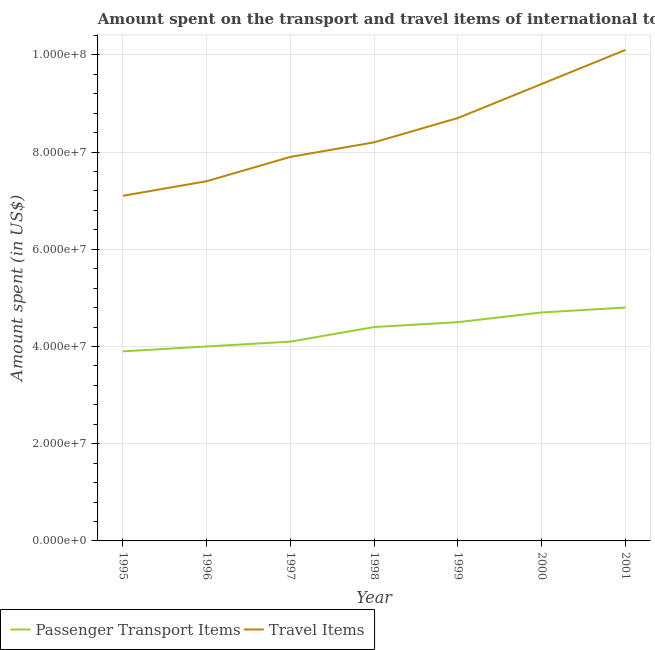How many different coloured lines are there?
Your answer should be very brief. 2. Does the line corresponding to amount spent in travel items intersect with the line corresponding to amount spent on passenger transport items?
Provide a succinct answer. No. Is the number of lines equal to the number of legend labels?
Ensure brevity in your answer.  Yes. What is the amount spent in travel items in 1997?
Make the answer very short. 7.90e+07. Across all years, what is the maximum amount spent on passenger transport items?
Give a very brief answer. 4.80e+07. Across all years, what is the minimum amount spent on passenger transport items?
Your answer should be compact. 3.90e+07. In which year was the amount spent on passenger transport items maximum?
Your answer should be very brief. 2001. What is the total amount spent in travel items in the graph?
Give a very brief answer. 5.88e+08. What is the difference between the amount spent on passenger transport items in 1996 and that in 1997?
Ensure brevity in your answer.  -1.00e+06. What is the difference between the amount spent on passenger transport items in 1998 and the amount spent in travel items in 1996?
Provide a short and direct response. -3.00e+07. What is the average amount spent in travel items per year?
Your answer should be compact. 8.40e+07. In the year 2000, what is the difference between the amount spent on passenger transport items and amount spent in travel items?
Make the answer very short. -4.70e+07. What is the ratio of the amount spent on passenger transport items in 1996 to that in 1997?
Offer a terse response. 0.98. Is the amount spent on passenger transport items in 1999 less than that in 2001?
Keep it short and to the point. Yes. Is the difference between the amount spent in travel items in 1995 and 1997 greater than the difference between the amount spent on passenger transport items in 1995 and 1997?
Your answer should be very brief. No. What is the difference between the highest and the lowest amount spent on passenger transport items?
Make the answer very short. 9.00e+06. In how many years, is the amount spent on passenger transport items greater than the average amount spent on passenger transport items taken over all years?
Provide a succinct answer. 4. Is the amount spent in travel items strictly less than the amount spent on passenger transport items over the years?
Offer a very short reply. No. How many years are there in the graph?
Provide a short and direct response. 7. What is the difference between two consecutive major ticks on the Y-axis?
Make the answer very short. 2.00e+07. Are the values on the major ticks of Y-axis written in scientific E-notation?
Give a very brief answer. Yes. Does the graph contain any zero values?
Provide a short and direct response. No. Does the graph contain grids?
Provide a short and direct response. Yes. How many legend labels are there?
Make the answer very short. 2. What is the title of the graph?
Offer a very short reply. Amount spent on the transport and travel items of international tourists visited in Barbados. Does "Drinking water services" appear as one of the legend labels in the graph?
Give a very brief answer. No. What is the label or title of the X-axis?
Make the answer very short. Year. What is the label or title of the Y-axis?
Make the answer very short. Amount spent (in US$). What is the Amount spent (in US$) in Passenger Transport Items in 1995?
Your response must be concise. 3.90e+07. What is the Amount spent (in US$) in Travel Items in 1995?
Your answer should be compact. 7.10e+07. What is the Amount spent (in US$) in Passenger Transport Items in 1996?
Offer a very short reply. 4.00e+07. What is the Amount spent (in US$) of Travel Items in 1996?
Your answer should be very brief. 7.40e+07. What is the Amount spent (in US$) in Passenger Transport Items in 1997?
Offer a very short reply. 4.10e+07. What is the Amount spent (in US$) in Travel Items in 1997?
Make the answer very short. 7.90e+07. What is the Amount spent (in US$) of Passenger Transport Items in 1998?
Your response must be concise. 4.40e+07. What is the Amount spent (in US$) of Travel Items in 1998?
Keep it short and to the point. 8.20e+07. What is the Amount spent (in US$) in Passenger Transport Items in 1999?
Offer a terse response. 4.50e+07. What is the Amount spent (in US$) of Travel Items in 1999?
Your response must be concise. 8.70e+07. What is the Amount spent (in US$) of Passenger Transport Items in 2000?
Your answer should be compact. 4.70e+07. What is the Amount spent (in US$) of Travel Items in 2000?
Make the answer very short. 9.40e+07. What is the Amount spent (in US$) of Passenger Transport Items in 2001?
Offer a very short reply. 4.80e+07. What is the Amount spent (in US$) in Travel Items in 2001?
Keep it short and to the point. 1.01e+08. Across all years, what is the maximum Amount spent (in US$) of Passenger Transport Items?
Give a very brief answer. 4.80e+07. Across all years, what is the maximum Amount spent (in US$) of Travel Items?
Keep it short and to the point. 1.01e+08. Across all years, what is the minimum Amount spent (in US$) in Passenger Transport Items?
Offer a terse response. 3.90e+07. Across all years, what is the minimum Amount spent (in US$) in Travel Items?
Your response must be concise. 7.10e+07. What is the total Amount spent (in US$) in Passenger Transport Items in the graph?
Provide a succinct answer. 3.04e+08. What is the total Amount spent (in US$) of Travel Items in the graph?
Provide a short and direct response. 5.88e+08. What is the difference between the Amount spent (in US$) of Passenger Transport Items in 1995 and that in 1996?
Your answer should be compact. -1.00e+06. What is the difference between the Amount spent (in US$) in Travel Items in 1995 and that in 1997?
Your response must be concise. -8.00e+06. What is the difference between the Amount spent (in US$) in Passenger Transport Items in 1995 and that in 1998?
Keep it short and to the point. -5.00e+06. What is the difference between the Amount spent (in US$) of Travel Items in 1995 and that in 1998?
Offer a very short reply. -1.10e+07. What is the difference between the Amount spent (in US$) in Passenger Transport Items in 1995 and that in 1999?
Offer a terse response. -6.00e+06. What is the difference between the Amount spent (in US$) in Travel Items in 1995 and that in 1999?
Offer a terse response. -1.60e+07. What is the difference between the Amount spent (in US$) of Passenger Transport Items in 1995 and that in 2000?
Ensure brevity in your answer.  -8.00e+06. What is the difference between the Amount spent (in US$) of Travel Items in 1995 and that in 2000?
Give a very brief answer. -2.30e+07. What is the difference between the Amount spent (in US$) in Passenger Transport Items in 1995 and that in 2001?
Your answer should be compact. -9.00e+06. What is the difference between the Amount spent (in US$) of Travel Items in 1995 and that in 2001?
Ensure brevity in your answer.  -3.00e+07. What is the difference between the Amount spent (in US$) of Passenger Transport Items in 1996 and that in 1997?
Ensure brevity in your answer.  -1.00e+06. What is the difference between the Amount spent (in US$) of Travel Items in 1996 and that in 1997?
Offer a very short reply. -5.00e+06. What is the difference between the Amount spent (in US$) of Passenger Transport Items in 1996 and that in 1998?
Make the answer very short. -4.00e+06. What is the difference between the Amount spent (in US$) in Travel Items in 1996 and that in 1998?
Give a very brief answer. -8.00e+06. What is the difference between the Amount spent (in US$) of Passenger Transport Items in 1996 and that in 1999?
Offer a terse response. -5.00e+06. What is the difference between the Amount spent (in US$) in Travel Items in 1996 and that in 1999?
Offer a very short reply. -1.30e+07. What is the difference between the Amount spent (in US$) of Passenger Transport Items in 1996 and that in 2000?
Your answer should be very brief. -7.00e+06. What is the difference between the Amount spent (in US$) in Travel Items in 1996 and that in 2000?
Your response must be concise. -2.00e+07. What is the difference between the Amount spent (in US$) in Passenger Transport Items in 1996 and that in 2001?
Offer a terse response. -8.00e+06. What is the difference between the Amount spent (in US$) of Travel Items in 1996 and that in 2001?
Give a very brief answer. -2.70e+07. What is the difference between the Amount spent (in US$) of Passenger Transport Items in 1997 and that in 1998?
Your answer should be very brief. -3.00e+06. What is the difference between the Amount spent (in US$) of Travel Items in 1997 and that in 1998?
Keep it short and to the point. -3.00e+06. What is the difference between the Amount spent (in US$) in Travel Items in 1997 and that in 1999?
Keep it short and to the point. -8.00e+06. What is the difference between the Amount spent (in US$) in Passenger Transport Items in 1997 and that in 2000?
Your response must be concise. -6.00e+06. What is the difference between the Amount spent (in US$) in Travel Items in 1997 and that in 2000?
Offer a terse response. -1.50e+07. What is the difference between the Amount spent (in US$) in Passenger Transport Items in 1997 and that in 2001?
Your answer should be compact. -7.00e+06. What is the difference between the Amount spent (in US$) in Travel Items in 1997 and that in 2001?
Give a very brief answer. -2.20e+07. What is the difference between the Amount spent (in US$) in Passenger Transport Items in 1998 and that in 1999?
Provide a succinct answer. -1.00e+06. What is the difference between the Amount spent (in US$) of Travel Items in 1998 and that in 1999?
Your response must be concise. -5.00e+06. What is the difference between the Amount spent (in US$) of Travel Items in 1998 and that in 2000?
Keep it short and to the point. -1.20e+07. What is the difference between the Amount spent (in US$) in Travel Items in 1998 and that in 2001?
Offer a very short reply. -1.90e+07. What is the difference between the Amount spent (in US$) of Travel Items in 1999 and that in 2000?
Offer a very short reply. -7.00e+06. What is the difference between the Amount spent (in US$) of Travel Items in 1999 and that in 2001?
Your answer should be very brief. -1.40e+07. What is the difference between the Amount spent (in US$) of Travel Items in 2000 and that in 2001?
Offer a very short reply. -7.00e+06. What is the difference between the Amount spent (in US$) of Passenger Transport Items in 1995 and the Amount spent (in US$) of Travel Items in 1996?
Your response must be concise. -3.50e+07. What is the difference between the Amount spent (in US$) of Passenger Transport Items in 1995 and the Amount spent (in US$) of Travel Items in 1997?
Make the answer very short. -4.00e+07. What is the difference between the Amount spent (in US$) of Passenger Transport Items in 1995 and the Amount spent (in US$) of Travel Items in 1998?
Give a very brief answer. -4.30e+07. What is the difference between the Amount spent (in US$) in Passenger Transport Items in 1995 and the Amount spent (in US$) in Travel Items in 1999?
Your answer should be very brief. -4.80e+07. What is the difference between the Amount spent (in US$) of Passenger Transport Items in 1995 and the Amount spent (in US$) of Travel Items in 2000?
Your answer should be compact. -5.50e+07. What is the difference between the Amount spent (in US$) in Passenger Transport Items in 1995 and the Amount spent (in US$) in Travel Items in 2001?
Make the answer very short. -6.20e+07. What is the difference between the Amount spent (in US$) of Passenger Transport Items in 1996 and the Amount spent (in US$) of Travel Items in 1997?
Provide a short and direct response. -3.90e+07. What is the difference between the Amount spent (in US$) in Passenger Transport Items in 1996 and the Amount spent (in US$) in Travel Items in 1998?
Your answer should be compact. -4.20e+07. What is the difference between the Amount spent (in US$) in Passenger Transport Items in 1996 and the Amount spent (in US$) in Travel Items in 1999?
Your response must be concise. -4.70e+07. What is the difference between the Amount spent (in US$) of Passenger Transport Items in 1996 and the Amount spent (in US$) of Travel Items in 2000?
Keep it short and to the point. -5.40e+07. What is the difference between the Amount spent (in US$) in Passenger Transport Items in 1996 and the Amount spent (in US$) in Travel Items in 2001?
Provide a short and direct response. -6.10e+07. What is the difference between the Amount spent (in US$) in Passenger Transport Items in 1997 and the Amount spent (in US$) in Travel Items in 1998?
Offer a very short reply. -4.10e+07. What is the difference between the Amount spent (in US$) in Passenger Transport Items in 1997 and the Amount spent (in US$) in Travel Items in 1999?
Ensure brevity in your answer.  -4.60e+07. What is the difference between the Amount spent (in US$) in Passenger Transport Items in 1997 and the Amount spent (in US$) in Travel Items in 2000?
Your answer should be very brief. -5.30e+07. What is the difference between the Amount spent (in US$) in Passenger Transport Items in 1997 and the Amount spent (in US$) in Travel Items in 2001?
Give a very brief answer. -6.00e+07. What is the difference between the Amount spent (in US$) of Passenger Transport Items in 1998 and the Amount spent (in US$) of Travel Items in 1999?
Make the answer very short. -4.30e+07. What is the difference between the Amount spent (in US$) in Passenger Transport Items in 1998 and the Amount spent (in US$) in Travel Items in 2000?
Keep it short and to the point. -5.00e+07. What is the difference between the Amount spent (in US$) in Passenger Transport Items in 1998 and the Amount spent (in US$) in Travel Items in 2001?
Ensure brevity in your answer.  -5.70e+07. What is the difference between the Amount spent (in US$) in Passenger Transport Items in 1999 and the Amount spent (in US$) in Travel Items in 2000?
Your answer should be very brief. -4.90e+07. What is the difference between the Amount spent (in US$) in Passenger Transport Items in 1999 and the Amount spent (in US$) in Travel Items in 2001?
Provide a short and direct response. -5.60e+07. What is the difference between the Amount spent (in US$) of Passenger Transport Items in 2000 and the Amount spent (in US$) of Travel Items in 2001?
Make the answer very short. -5.40e+07. What is the average Amount spent (in US$) in Passenger Transport Items per year?
Your response must be concise. 4.34e+07. What is the average Amount spent (in US$) in Travel Items per year?
Keep it short and to the point. 8.40e+07. In the year 1995, what is the difference between the Amount spent (in US$) in Passenger Transport Items and Amount spent (in US$) in Travel Items?
Your answer should be very brief. -3.20e+07. In the year 1996, what is the difference between the Amount spent (in US$) in Passenger Transport Items and Amount spent (in US$) in Travel Items?
Your answer should be compact. -3.40e+07. In the year 1997, what is the difference between the Amount spent (in US$) in Passenger Transport Items and Amount spent (in US$) in Travel Items?
Offer a terse response. -3.80e+07. In the year 1998, what is the difference between the Amount spent (in US$) in Passenger Transport Items and Amount spent (in US$) in Travel Items?
Your answer should be very brief. -3.80e+07. In the year 1999, what is the difference between the Amount spent (in US$) in Passenger Transport Items and Amount spent (in US$) in Travel Items?
Your response must be concise. -4.20e+07. In the year 2000, what is the difference between the Amount spent (in US$) in Passenger Transport Items and Amount spent (in US$) in Travel Items?
Make the answer very short. -4.70e+07. In the year 2001, what is the difference between the Amount spent (in US$) in Passenger Transport Items and Amount spent (in US$) in Travel Items?
Keep it short and to the point. -5.30e+07. What is the ratio of the Amount spent (in US$) of Travel Items in 1995 to that in 1996?
Make the answer very short. 0.96. What is the ratio of the Amount spent (in US$) of Passenger Transport Items in 1995 to that in 1997?
Your answer should be very brief. 0.95. What is the ratio of the Amount spent (in US$) of Travel Items in 1995 to that in 1997?
Make the answer very short. 0.9. What is the ratio of the Amount spent (in US$) in Passenger Transport Items in 1995 to that in 1998?
Give a very brief answer. 0.89. What is the ratio of the Amount spent (in US$) of Travel Items in 1995 to that in 1998?
Make the answer very short. 0.87. What is the ratio of the Amount spent (in US$) in Passenger Transport Items in 1995 to that in 1999?
Offer a very short reply. 0.87. What is the ratio of the Amount spent (in US$) of Travel Items in 1995 to that in 1999?
Ensure brevity in your answer.  0.82. What is the ratio of the Amount spent (in US$) of Passenger Transport Items in 1995 to that in 2000?
Ensure brevity in your answer.  0.83. What is the ratio of the Amount spent (in US$) in Travel Items in 1995 to that in 2000?
Your response must be concise. 0.76. What is the ratio of the Amount spent (in US$) of Passenger Transport Items in 1995 to that in 2001?
Provide a succinct answer. 0.81. What is the ratio of the Amount spent (in US$) in Travel Items in 1995 to that in 2001?
Offer a terse response. 0.7. What is the ratio of the Amount spent (in US$) of Passenger Transport Items in 1996 to that in 1997?
Provide a succinct answer. 0.98. What is the ratio of the Amount spent (in US$) of Travel Items in 1996 to that in 1997?
Your answer should be compact. 0.94. What is the ratio of the Amount spent (in US$) of Passenger Transport Items in 1996 to that in 1998?
Provide a short and direct response. 0.91. What is the ratio of the Amount spent (in US$) of Travel Items in 1996 to that in 1998?
Your response must be concise. 0.9. What is the ratio of the Amount spent (in US$) in Travel Items in 1996 to that in 1999?
Your response must be concise. 0.85. What is the ratio of the Amount spent (in US$) of Passenger Transport Items in 1996 to that in 2000?
Offer a terse response. 0.85. What is the ratio of the Amount spent (in US$) in Travel Items in 1996 to that in 2000?
Offer a terse response. 0.79. What is the ratio of the Amount spent (in US$) of Passenger Transport Items in 1996 to that in 2001?
Ensure brevity in your answer.  0.83. What is the ratio of the Amount spent (in US$) of Travel Items in 1996 to that in 2001?
Your answer should be compact. 0.73. What is the ratio of the Amount spent (in US$) in Passenger Transport Items in 1997 to that in 1998?
Keep it short and to the point. 0.93. What is the ratio of the Amount spent (in US$) in Travel Items in 1997 to that in 1998?
Keep it short and to the point. 0.96. What is the ratio of the Amount spent (in US$) of Passenger Transport Items in 1997 to that in 1999?
Your response must be concise. 0.91. What is the ratio of the Amount spent (in US$) of Travel Items in 1997 to that in 1999?
Offer a very short reply. 0.91. What is the ratio of the Amount spent (in US$) of Passenger Transport Items in 1997 to that in 2000?
Keep it short and to the point. 0.87. What is the ratio of the Amount spent (in US$) in Travel Items in 1997 to that in 2000?
Make the answer very short. 0.84. What is the ratio of the Amount spent (in US$) in Passenger Transport Items in 1997 to that in 2001?
Offer a terse response. 0.85. What is the ratio of the Amount spent (in US$) of Travel Items in 1997 to that in 2001?
Offer a very short reply. 0.78. What is the ratio of the Amount spent (in US$) in Passenger Transport Items in 1998 to that in 1999?
Make the answer very short. 0.98. What is the ratio of the Amount spent (in US$) of Travel Items in 1998 to that in 1999?
Provide a succinct answer. 0.94. What is the ratio of the Amount spent (in US$) of Passenger Transport Items in 1998 to that in 2000?
Your answer should be very brief. 0.94. What is the ratio of the Amount spent (in US$) in Travel Items in 1998 to that in 2000?
Your answer should be compact. 0.87. What is the ratio of the Amount spent (in US$) in Passenger Transport Items in 1998 to that in 2001?
Offer a terse response. 0.92. What is the ratio of the Amount spent (in US$) in Travel Items in 1998 to that in 2001?
Provide a short and direct response. 0.81. What is the ratio of the Amount spent (in US$) in Passenger Transport Items in 1999 to that in 2000?
Offer a terse response. 0.96. What is the ratio of the Amount spent (in US$) in Travel Items in 1999 to that in 2000?
Offer a terse response. 0.93. What is the ratio of the Amount spent (in US$) of Passenger Transport Items in 1999 to that in 2001?
Your answer should be compact. 0.94. What is the ratio of the Amount spent (in US$) in Travel Items in 1999 to that in 2001?
Offer a very short reply. 0.86. What is the ratio of the Amount spent (in US$) in Passenger Transport Items in 2000 to that in 2001?
Offer a very short reply. 0.98. What is the ratio of the Amount spent (in US$) in Travel Items in 2000 to that in 2001?
Provide a succinct answer. 0.93. What is the difference between the highest and the second highest Amount spent (in US$) in Travel Items?
Your response must be concise. 7.00e+06. What is the difference between the highest and the lowest Amount spent (in US$) of Passenger Transport Items?
Offer a very short reply. 9.00e+06. What is the difference between the highest and the lowest Amount spent (in US$) of Travel Items?
Your answer should be compact. 3.00e+07. 